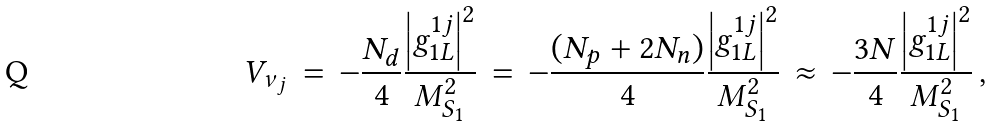Convert formula to latex. <formula><loc_0><loc_0><loc_500><loc_500>V _ { \nu _ { j } } \, = \, - \frac { N _ { d } } { 4 } \frac { \left | g _ { 1 L } ^ { 1 j } \right | ^ { 2 } } { M _ { S _ { 1 } } ^ { 2 } } \, = \, - \frac { ( N _ { p } + 2 N _ { n } ) } { 4 } \frac { \left | g _ { 1 L } ^ { 1 j } \right | ^ { 2 } } { M _ { S _ { 1 } } ^ { 2 } } \, \approx \, - \frac { 3 N } { 4 } \frac { \left | g _ { 1 L } ^ { 1 j } \right | ^ { 2 } } { M _ { S _ { 1 } } ^ { 2 } } \, ,</formula> 